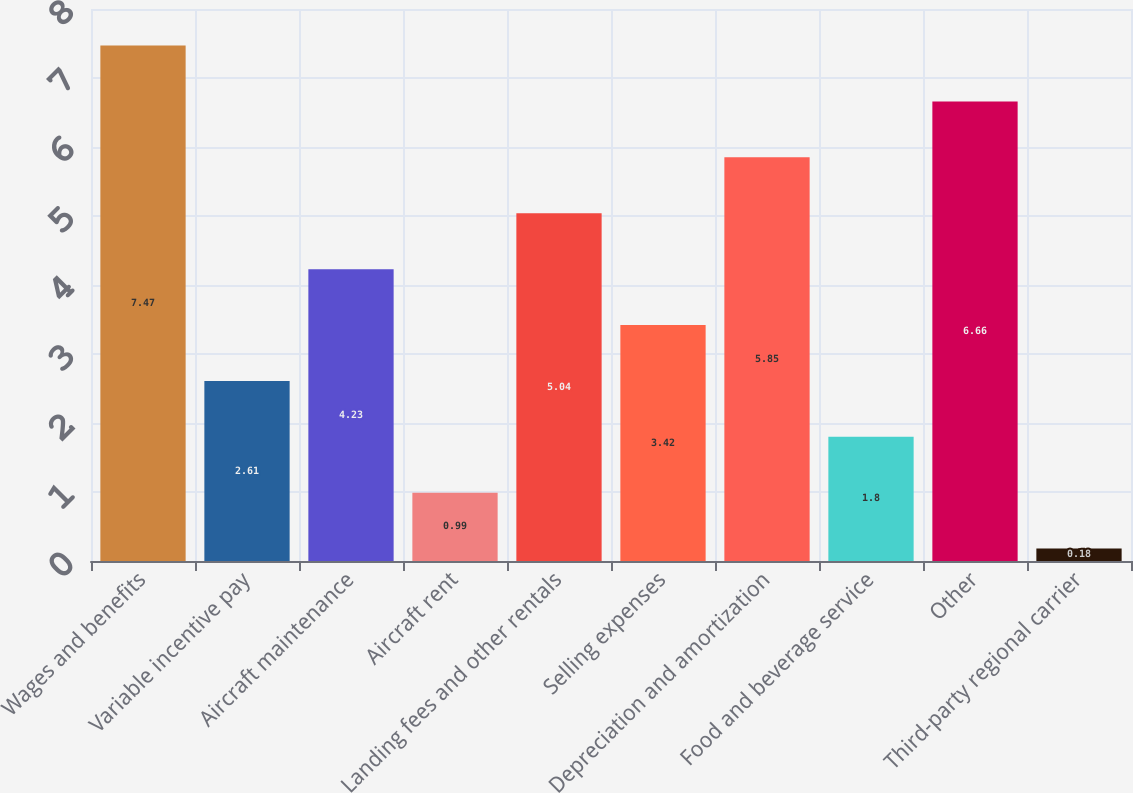<chart> <loc_0><loc_0><loc_500><loc_500><bar_chart><fcel>Wages and benefits<fcel>Variable incentive pay<fcel>Aircraft maintenance<fcel>Aircraft rent<fcel>Landing fees and other rentals<fcel>Selling expenses<fcel>Depreciation and amortization<fcel>Food and beverage service<fcel>Other<fcel>Third-party regional carrier<nl><fcel>7.47<fcel>2.61<fcel>4.23<fcel>0.99<fcel>5.04<fcel>3.42<fcel>5.85<fcel>1.8<fcel>6.66<fcel>0.18<nl></chart> 